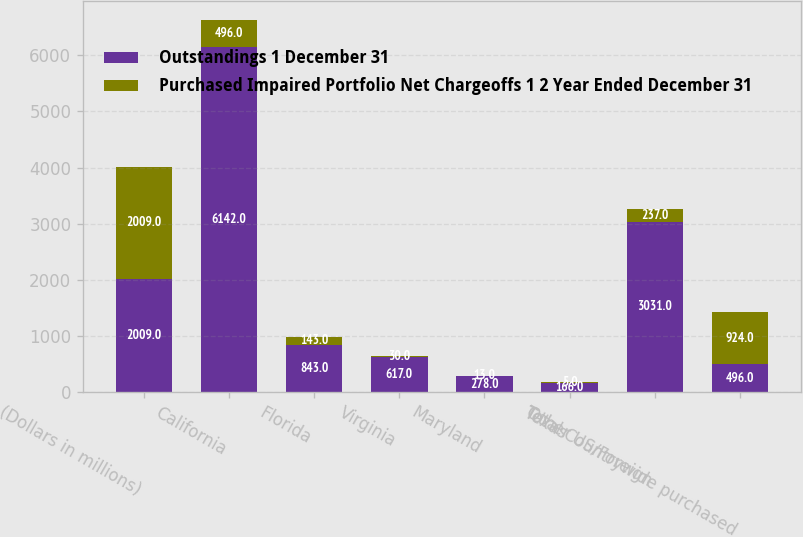Convert chart. <chart><loc_0><loc_0><loc_500><loc_500><stacked_bar_chart><ecel><fcel>(Dollars in millions)<fcel>California<fcel>Florida<fcel>Virginia<fcel>Maryland<fcel>Texas<fcel>Other US/Foreign<fcel>Total Countrywide purchased<nl><fcel>Outstandings 1 December 31<fcel>2009<fcel>6142<fcel>843<fcel>617<fcel>278<fcel>166<fcel>3031<fcel>496<nl><fcel>Purchased Impaired Portfolio Net Chargeoffs 1 2 Year Ended December 31<fcel>2009<fcel>496<fcel>143<fcel>30<fcel>13<fcel>5<fcel>237<fcel>924<nl></chart> 